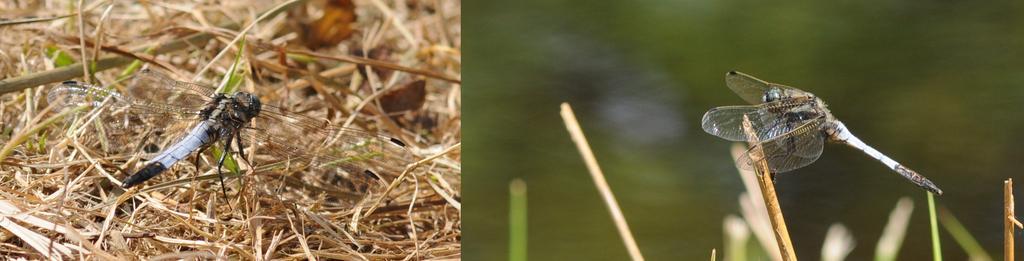Describe this image in one or two sentences. In this image I can see it is the photo collage, on the left side there is a dragonfly is standing on the dried grass, on the right side there is another dragon fly is standing on the dried stick. 